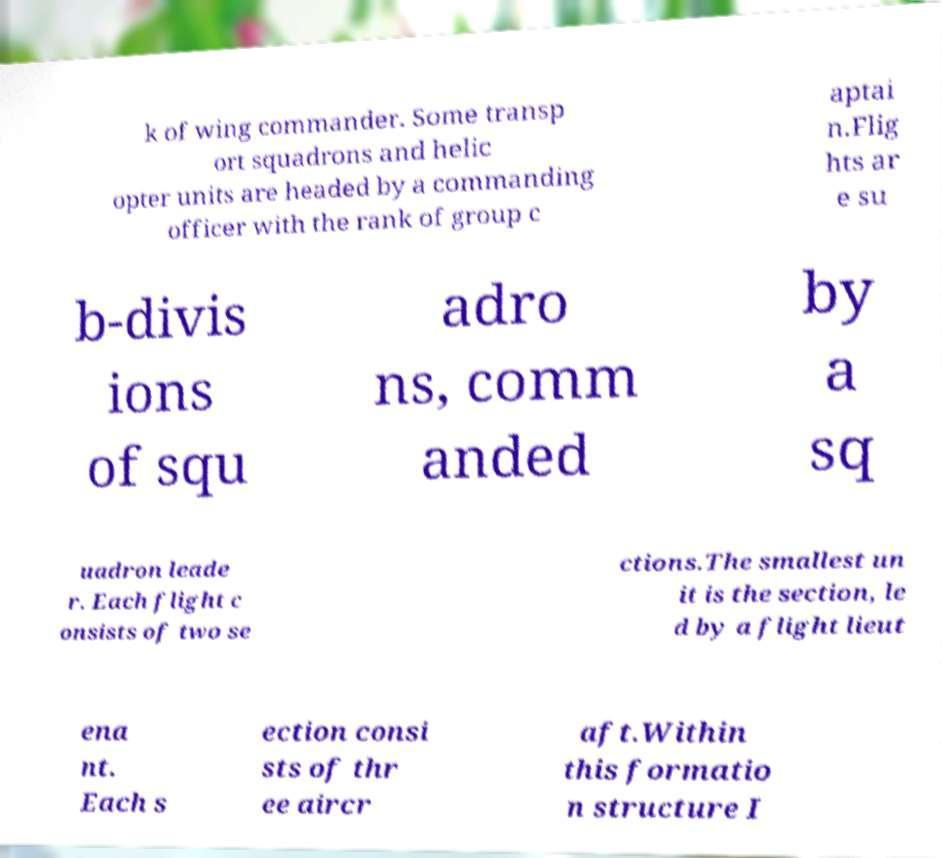What messages or text are displayed in this image? I need them in a readable, typed format. k of wing commander. Some transp ort squadrons and helic opter units are headed by a commanding officer with the rank of group c aptai n.Flig hts ar e su b-divis ions of squ adro ns, comm anded by a sq uadron leade r. Each flight c onsists of two se ctions.The smallest un it is the section, le d by a flight lieut ena nt. Each s ection consi sts of thr ee aircr aft.Within this formatio n structure I 